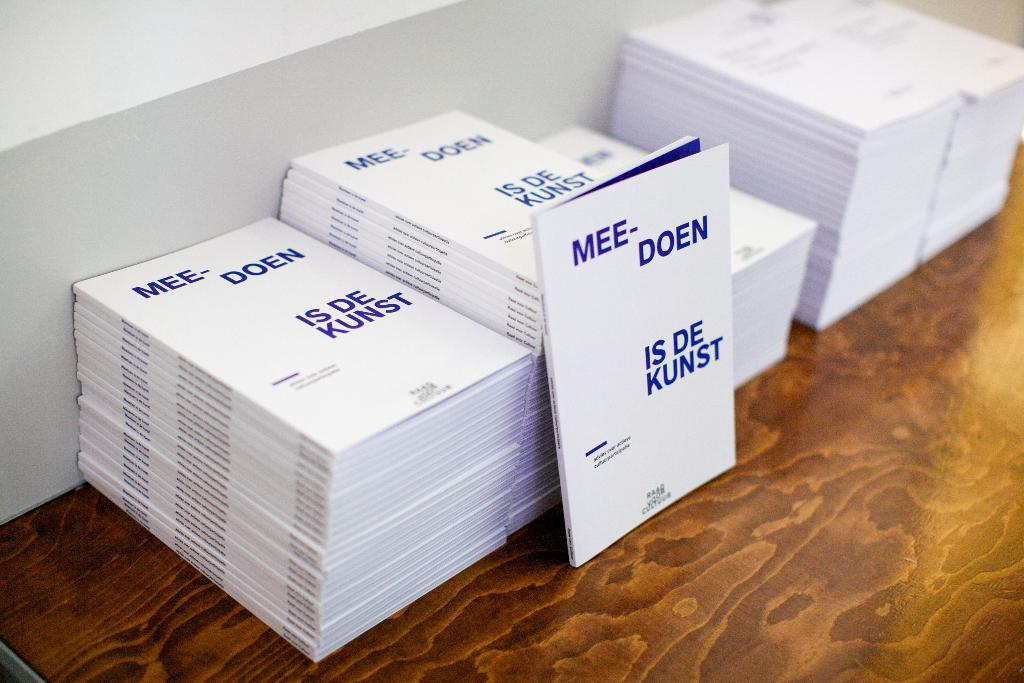<image>
Create a compact narrative representing the image presented. Mee Doen is de Kunst booklets stacked on top of each other 